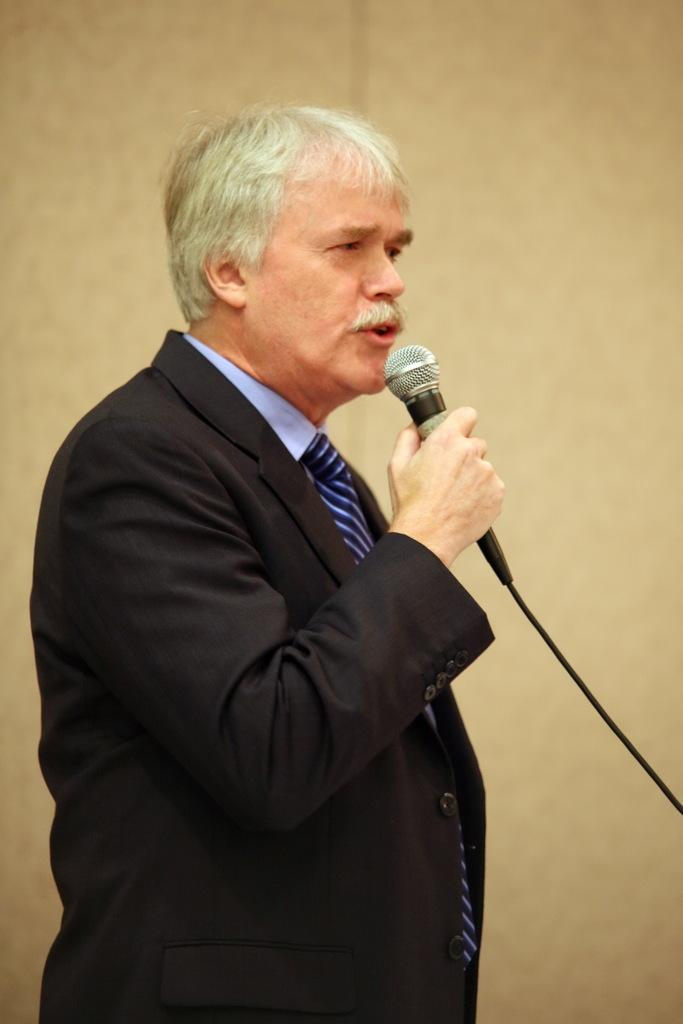What is the main subject of the image? There is a person in the image. What is the person doing in the image? The person is standing and holding a microphone in his hands. What can be seen in the background of the image? There is a wall in the background of the image. Can you see the person's daughter in the image? There is no mention of a daughter in the image, so it cannot be determined if the person has a daughter present. 